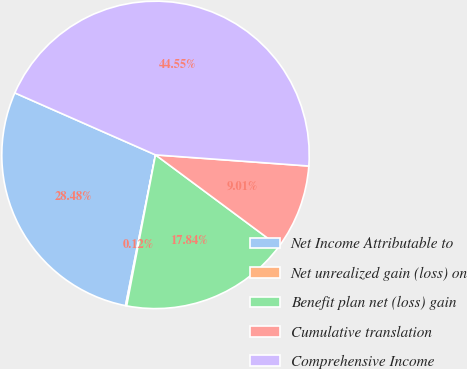<chart> <loc_0><loc_0><loc_500><loc_500><pie_chart><fcel>Net Income Attributable to<fcel>Net unrealized gain (loss) on<fcel>Benefit plan net (loss) gain<fcel>Cumulative translation<fcel>Comprehensive Income<nl><fcel>28.48%<fcel>0.12%<fcel>17.84%<fcel>9.01%<fcel>44.55%<nl></chart> 